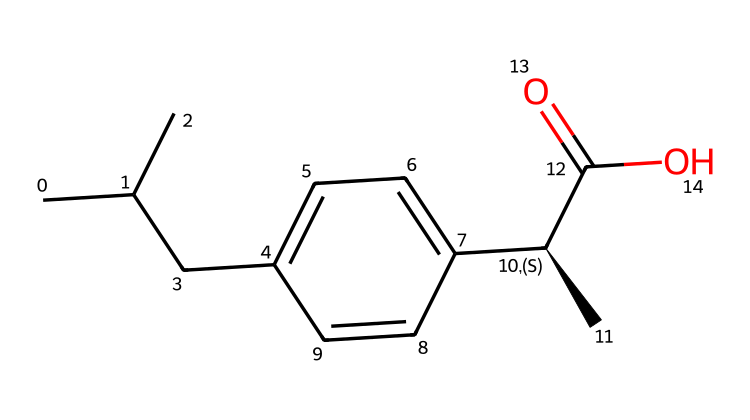What is the functional group present in ibuprofen? The presence of the carboxylic acid group can be identified by looking at the "-C(=O)O" part of the SMILES. This indicates that ibuprofen has a functional group typical of acidic compounds.
Answer: carboxylic acid How many carbon atoms are in ibuprofen? By analyzing the SMILES representation, you can count the carbon atoms represented in the structure. There are a total of 13 carbon atoms present in the chemical structure of ibuprofen.
Answer: 13 What type of chemical compound is ibuprofen? Ibuprofen is classified as a nonsteroidal anti-inflammatory drug (NSAID). This classification is typically due to its structure which includes the functional group of carboxylic acid and an aromatic ring, characteristic of NSAIDs.
Answer: NSAID How many double bonds are in the ibuprofen structure? In the provided SMILES string, the double bond is identified in the "-C(=O)-" part representing the carbonyl and in the aromatic ring where there are alternating double bonds. Upon review, there are two distinct double bonds in the overall structure.
Answer: 2 Which part of ibuprofen contributes to its anti-inflammatory properties? The aromatic ring and the carboxylic acid functional group together play crucial roles in the mechanism of action of ibuprofen, allowing it to block the cyclooxygenase enzymes (COX). The carboxylic acid group particularly is key for binding.
Answer: aromatic ring and carboxylic acid What is the stereochemistry of ibuprofen? The stereochemistry of ibuprofen is indicated by the "[C@H]" notation in the SMILES representation. The "@" symbol specifies that this carbon is chiral and introduces a stereocenter in the structure, which influences the activity of the compound.
Answer: chiral 